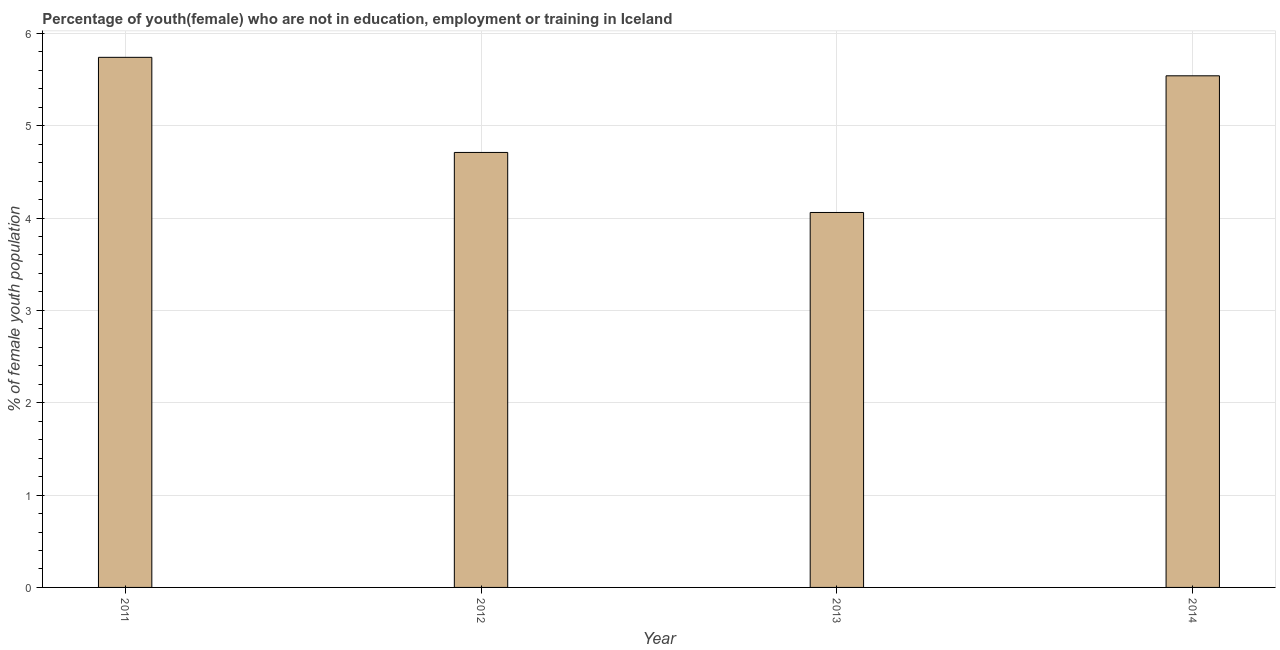What is the title of the graph?
Your answer should be compact. Percentage of youth(female) who are not in education, employment or training in Iceland. What is the label or title of the X-axis?
Your answer should be very brief. Year. What is the label or title of the Y-axis?
Ensure brevity in your answer.  % of female youth population. What is the unemployed female youth population in 2012?
Give a very brief answer. 4.71. Across all years, what is the maximum unemployed female youth population?
Offer a very short reply. 5.74. Across all years, what is the minimum unemployed female youth population?
Your answer should be very brief. 4.06. In which year was the unemployed female youth population maximum?
Make the answer very short. 2011. What is the sum of the unemployed female youth population?
Provide a succinct answer. 20.05. What is the difference between the unemployed female youth population in 2013 and 2014?
Your response must be concise. -1.48. What is the average unemployed female youth population per year?
Your response must be concise. 5.01. What is the median unemployed female youth population?
Keep it short and to the point. 5.12. In how many years, is the unemployed female youth population greater than 4.4 %?
Your answer should be compact. 3. Do a majority of the years between 2013 and 2012 (inclusive) have unemployed female youth population greater than 5.8 %?
Provide a short and direct response. No. What is the ratio of the unemployed female youth population in 2011 to that in 2012?
Offer a terse response. 1.22. Is the unemployed female youth population in 2011 less than that in 2014?
Ensure brevity in your answer.  No. Is the difference between the unemployed female youth population in 2012 and 2013 greater than the difference between any two years?
Your response must be concise. No. What is the difference between the highest and the second highest unemployed female youth population?
Ensure brevity in your answer.  0.2. Is the sum of the unemployed female youth population in 2011 and 2013 greater than the maximum unemployed female youth population across all years?
Provide a short and direct response. Yes. What is the difference between the highest and the lowest unemployed female youth population?
Keep it short and to the point. 1.68. In how many years, is the unemployed female youth population greater than the average unemployed female youth population taken over all years?
Offer a very short reply. 2. How many years are there in the graph?
Offer a very short reply. 4. What is the difference between two consecutive major ticks on the Y-axis?
Provide a short and direct response. 1. Are the values on the major ticks of Y-axis written in scientific E-notation?
Offer a very short reply. No. What is the % of female youth population in 2011?
Give a very brief answer. 5.74. What is the % of female youth population of 2012?
Keep it short and to the point. 4.71. What is the % of female youth population of 2013?
Keep it short and to the point. 4.06. What is the % of female youth population of 2014?
Offer a terse response. 5.54. What is the difference between the % of female youth population in 2011 and 2013?
Offer a very short reply. 1.68. What is the difference between the % of female youth population in 2011 and 2014?
Provide a short and direct response. 0.2. What is the difference between the % of female youth population in 2012 and 2013?
Your answer should be compact. 0.65. What is the difference between the % of female youth population in 2012 and 2014?
Your answer should be very brief. -0.83. What is the difference between the % of female youth population in 2013 and 2014?
Offer a terse response. -1.48. What is the ratio of the % of female youth population in 2011 to that in 2012?
Provide a succinct answer. 1.22. What is the ratio of the % of female youth population in 2011 to that in 2013?
Your response must be concise. 1.41. What is the ratio of the % of female youth population in 2011 to that in 2014?
Provide a short and direct response. 1.04. What is the ratio of the % of female youth population in 2012 to that in 2013?
Keep it short and to the point. 1.16. What is the ratio of the % of female youth population in 2012 to that in 2014?
Your answer should be very brief. 0.85. What is the ratio of the % of female youth population in 2013 to that in 2014?
Offer a very short reply. 0.73. 